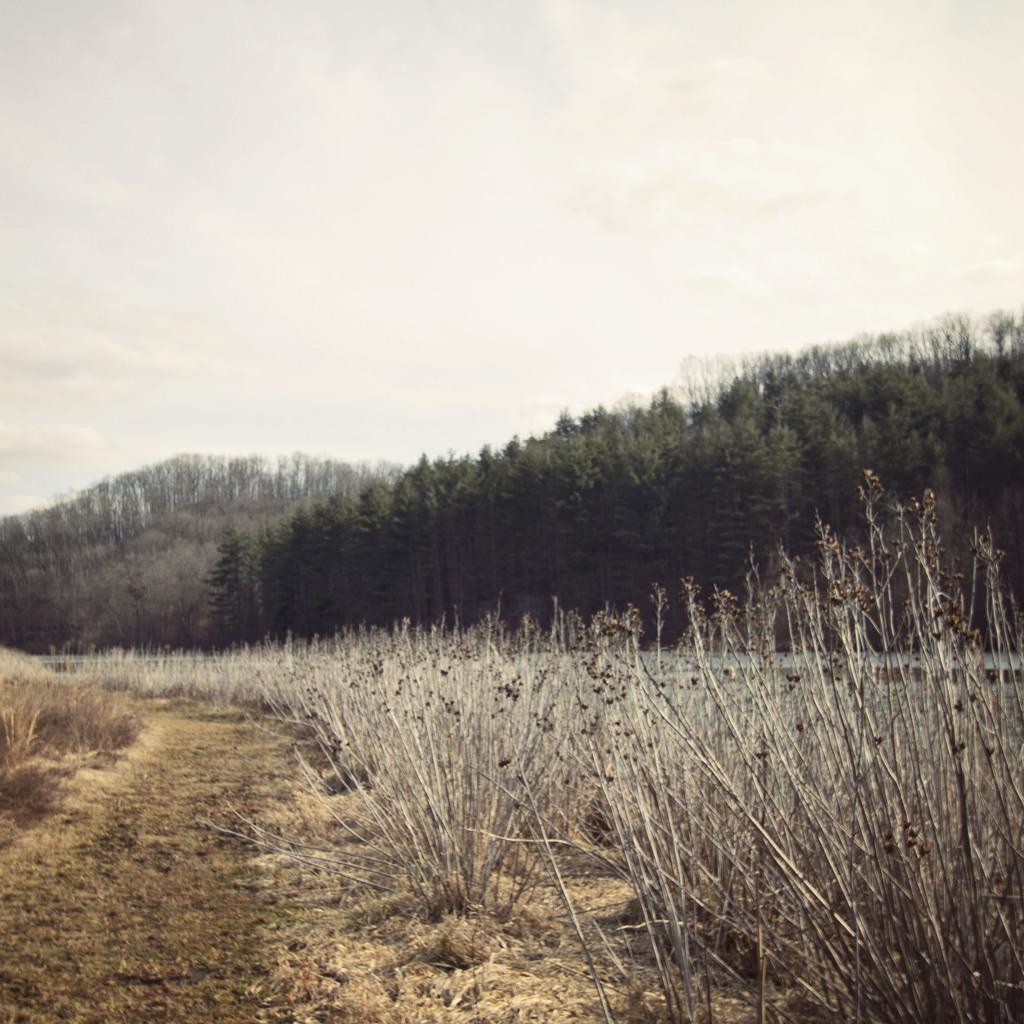What type of vegetation is at the bottom of the image? There are dried plants at the bottom of the image. What type of vegetation is on the right side of the image? There are green trees on the right side of the image. What is visible at the top of the image? The sky is visible at the top of the image. How many jellyfish can be seen swimming in the image? There are no jellyfish present in the image. What are the girls doing in the image? There are no girls present in the image. 